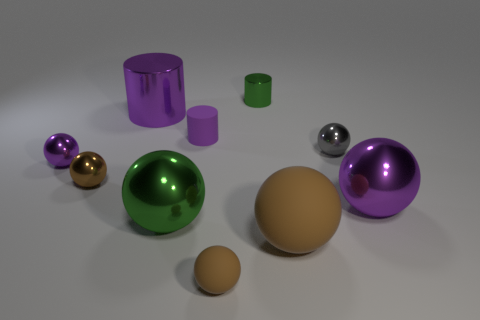Subtract all purple cylinders. How many brown balls are left? 3 Subtract 4 spheres. How many spheres are left? 3 Subtract all purple metallic balls. How many balls are left? 5 Subtract all green balls. How many balls are left? 6 Subtract all purple balls. Subtract all yellow cylinders. How many balls are left? 5 Subtract all cylinders. How many objects are left? 7 Subtract all tiny cylinders. Subtract all matte things. How many objects are left? 5 Add 8 tiny matte things. How many tiny matte things are left? 10 Add 5 tiny green cylinders. How many tiny green cylinders exist? 6 Subtract 1 green balls. How many objects are left? 9 